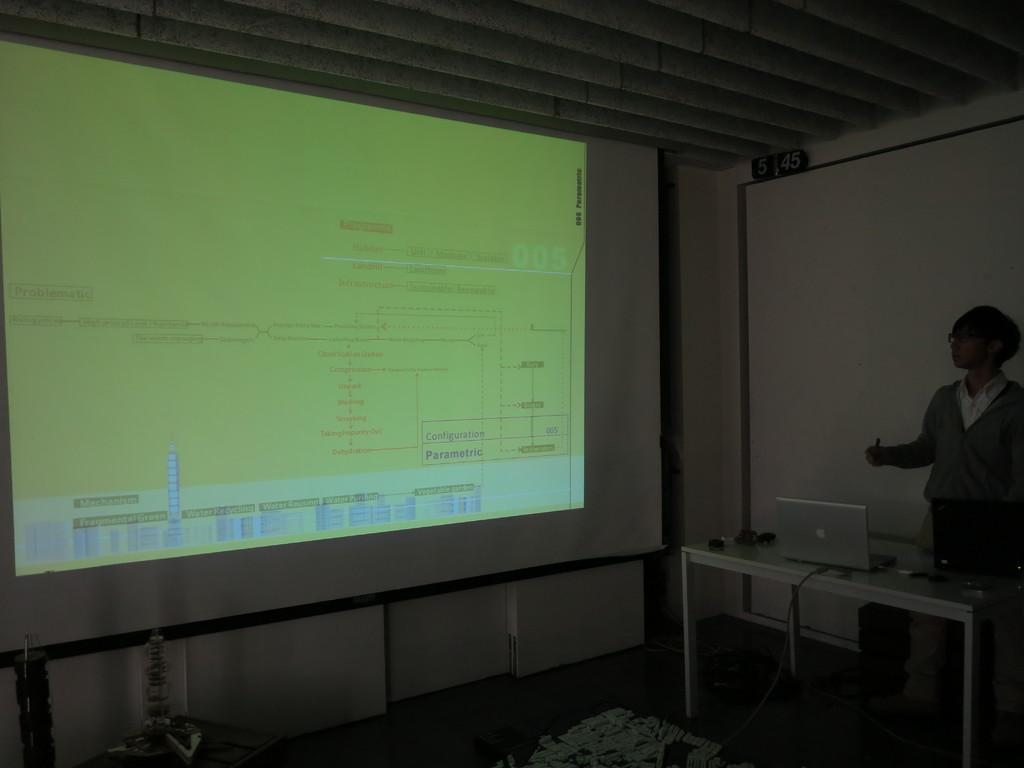What is the main subject in the image? There is a man standing in the image. What can be seen in the background of the image? The image is taken on a rooftop. What is on the table in the image? There is a laptop and other objects on the table. What is the purpose of the screen with a display in the image? The purpose of the screen with a display is not specified, but it could be related to the laptop or another device. How many chickens are present on the rooftop in the image? There are no chickens present in the image; it features a man standing on a rooftop with a table and laptop. Is the man wearing a mask in the image? There is no mention of a mask in the image, and the man's face is visible. 